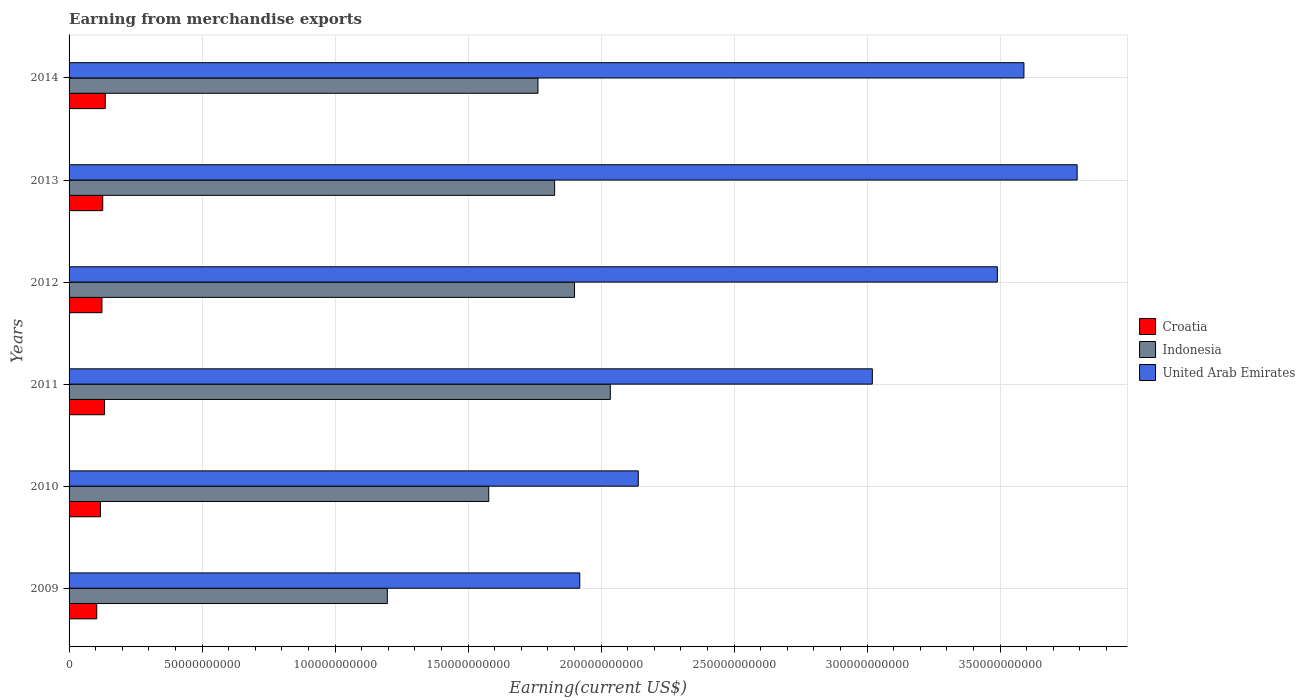How many different coloured bars are there?
Your answer should be compact. 3. How many groups of bars are there?
Make the answer very short. 6. Are the number of bars per tick equal to the number of legend labels?
Your answer should be very brief. Yes. How many bars are there on the 3rd tick from the top?
Give a very brief answer. 3. How many bars are there on the 4th tick from the bottom?
Provide a succinct answer. 3. What is the label of the 1st group of bars from the top?
Keep it short and to the point. 2014. What is the amount earned from merchandise exports in United Arab Emirates in 2012?
Give a very brief answer. 3.49e+11. Across all years, what is the maximum amount earned from merchandise exports in Indonesia?
Provide a succinct answer. 2.03e+11. Across all years, what is the minimum amount earned from merchandise exports in Croatia?
Ensure brevity in your answer.  1.04e+1. In which year was the amount earned from merchandise exports in Indonesia maximum?
Provide a short and direct response. 2011. What is the total amount earned from merchandise exports in Indonesia in the graph?
Give a very brief answer. 1.03e+12. What is the difference between the amount earned from merchandise exports in Indonesia in 2011 and that in 2013?
Offer a terse response. 2.09e+1. What is the difference between the amount earned from merchandise exports in United Arab Emirates in 2009 and the amount earned from merchandise exports in Croatia in 2013?
Ensure brevity in your answer.  1.79e+11. What is the average amount earned from merchandise exports in Indonesia per year?
Give a very brief answer. 1.72e+11. In the year 2012, what is the difference between the amount earned from merchandise exports in Croatia and amount earned from merchandise exports in United Arab Emirates?
Your response must be concise. -3.37e+11. What is the ratio of the amount earned from merchandise exports in Indonesia in 2012 to that in 2014?
Give a very brief answer. 1.08. What is the difference between the highest and the second highest amount earned from merchandise exports in Indonesia?
Ensure brevity in your answer.  1.35e+1. What is the difference between the highest and the lowest amount earned from merchandise exports in Croatia?
Offer a very short reply. 3.20e+09. In how many years, is the amount earned from merchandise exports in United Arab Emirates greater than the average amount earned from merchandise exports in United Arab Emirates taken over all years?
Your answer should be very brief. 4. What does the 1st bar from the top in 2010 represents?
Ensure brevity in your answer.  United Arab Emirates. What does the 1st bar from the bottom in 2009 represents?
Provide a short and direct response. Croatia. Is it the case that in every year, the sum of the amount earned from merchandise exports in Indonesia and amount earned from merchandise exports in Croatia is greater than the amount earned from merchandise exports in United Arab Emirates?
Provide a short and direct response. No. How many bars are there?
Make the answer very short. 18. Does the graph contain any zero values?
Give a very brief answer. No. Does the graph contain grids?
Offer a terse response. Yes. Where does the legend appear in the graph?
Ensure brevity in your answer.  Center right. How are the legend labels stacked?
Offer a terse response. Vertical. What is the title of the graph?
Offer a very short reply. Earning from merchandise exports. What is the label or title of the X-axis?
Offer a very short reply. Earning(current US$). What is the Earning(current US$) in Croatia in 2009?
Ensure brevity in your answer.  1.04e+1. What is the Earning(current US$) of Indonesia in 2009?
Your answer should be very brief. 1.20e+11. What is the Earning(current US$) in United Arab Emirates in 2009?
Ensure brevity in your answer.  1.92e+11. What is the Earning(current US$) of Croatia in 2010?
Offer a very short reply. 1.18e+1. What is the Earning(current US$) of Indonesia in 2010?
Your answer should be very brief. 1.58e+11. What is the Earning(current US$) in United Arab Emirates in 2010?
Give a very brief answer. 2.14e+11. What is the Earning(current US$) of Croatia in 2011?
Provide a succinct answer. 1.33e+1. What is the Earning(current US$) of Indonesia in 2011?
Provide a succinct answer. 2.03e+11. What is the Earning(current US$) in United Arab Emirates in 2011?
Offer a very short reply. 3.02e+11. What is the Earning(current US$) in Croatia in 2012?
Give a very brief answer. 1.24e+1. What is the Earning(current US$) of Indonesia in 2012?
Offer a terse response. 1.90e+11. What is the Earning(current US$) of United Arab Emirates in 2012?
Keep it short and to the point. 3.49e+11. What is the Earning(current US$) in Croatia in 2013?
Your response must be concise. 1.27e+1. What is the Earning(current US$) of Indonesia in 2013?
Your answer should be very brief. 1.83e+11. What is the Earning(current US$) in United Arab Emirates in 2013?
Provide a succinct answer. 3.79e+11. What is the Earning(current US$) in Croatia in 2014?
Give a very brief answer. 1.36e+1. What is the Earning(current US$) in Indonesia in 2014?
Provide a succinct answer. 1.76e+11. What is the Earning(current US$) of United Arab Emirates in 2014?
Give a very brief answer. 3.59e+11. Across all years, what is the maximum Earning(current US$) in Croatia?
Your answer should be very brief. 1.36e+1. Across all years, what is the maximum Earning(current US$) in Indonesia?
Offer a very short reply. 2.03e+11. Across all years, what is the maximum Earning(current US$) in United Arab Emirates?
Keep it short and to the point. 3.79e+11. Across all years, what is the minimum Earning(current US$) in Croatia?
Your answer should be compact. 1.04e+1. Across all years, what is the minimum Earning(current US$) of Indonesia?
Ensure brevity in your answer.  1.20e+11. Across all years, what is the minimum Earning(current US$) of United Arab Emirates?
Your response must be concise. 1.92e+11. What is the total Earning(current US$) in Croatia in the graph?
Make the answer very short. 7.42e+1. What is the total Earning(current US$) in Indonesia in the graph?
Offer a very short reply. 1.03e+12. What is the total Earning(current US$) of United Arab Emirates in the graph?
Keep it short and to the point. 1.80e+12. What is the difference between the Earning(current US$) in Croatia in 2009 and that in 2010?
Offer a terse response. -1.40e+09. What is the difference between the Earning(current US$) of Indonesia in 2009 and that in 2010?
Your answer should be compact. -3.81e+1. What is the difference between the Earning(current US$) of United Arab Emirates in 2009 and that in 2010?
Give a very brief answer. -2.20e+1. What is the difference between the Earning(current US$) in Croatia in 2009 and that in 2011?
Offer a terse response. -2.94e+09. What is the difference between the Earning(current US$) of Indonesia in 2009 and that in 2011?
Keep it short and to the point. -8.39e+1. What is the difference between the Earning(current US$) in United Arab Emirates in 2009 and that in 2011?
Make the answer very short. -1.10e+11. What is the difference between the Earning(current US$) in Croatia in 2009 and that in 2012?
Your answer should be very brief. -1.97e+09. What is the difference between the Earning(current US$) of Indonesia in 2009 and that in 2012?
Make the answer very short. -7.04e+1. What is the difference between the Earning(current US$) of United Arab Emirates in 2009 and that in 2012?
Keep it short and to the point. -1.57e+11. What is the difference between the Earning(current US$) of Croatia in 2009 and that in 2013?
Give a very brief answer. -2.26e+09. What is the difference between the Earning(current US$) of Indonesia in 2009 and that in 2013?
Provide a succinct answer. -6.29e+1. What is the difference between the Earning(current US$) of United Arab Emirates in 2009 and that in 2013?
Your response must be concise. -1.87e+11. What is the difference between the Earning(current US$) of Croatia in 2009 and that in 2014?
Offer a very short reply. -3.20e+09. What is the difference between the Earning(current US$) in Indonesia in 2009 and that in 2014?
Provide a short and direct response. -5.66e+1. What is the difference between the Earning(current US$) in United Arab Emirates in 2009 and that in 2014?
Offer a terse response. -1.67e+11. What is the difference between the Earning(current US$) of Croatia in 2010 and that in 2011?
Offer a very short reply. -1.53e+09. What is the difference between the Earning(current US$) in Indonesia in 2010 and that in 2011?
Keep it short and to the point. -4.57e+1. What is the difference between the Earning(current US$) in United Arab Emirates in 2010 and that in 2011?
Your answer should be very brief. -8.80e+1. What is the difference between the Earning(current US$) in Croatia in 2010 and that in 2012?
Offer a very short reply. -5.65e+08. What is the difference between the Earning(current US$) in Indonesia in 2010 and that in 2012?
Your answer should be very brief. -3.23e+1. What is the difference between the Earning(current US$) of United Arab Emirates in 2010 and that in 2012?
Ensure brevity in your answer.  -1.35e+11. What is the difference between the Earning(current US$) of Croatia in 2010 and that in 2013?
Offer a terse response. -8.53e+08. What is the difference between the Earning(current US$) of Indonesia in 2010 and that in 2013?
Keep it short and to the point. -2.48e+1. What is the difference between the Earning(current US$) in United Arab Emirates in 2010 and that in 2013?
Ensure brevity in your answer.  -1.65e+11. What is the difference between the Earning(current US$) of Croatia in 2010 and that in 2014?
Provide a short and direct response. -1.80e+09. What is the difference between the Earning(current US$) of Indonesia in 2010 and that in 2014?
Give a very brief answer. -1.85e+1. What is the difference between the Earning(current US$) of United Arab Emirates in 2010 and that in 2014?
Offer a terse response. -1.45e+11. What is the difference between the Earning(current US$) in Croatia in 2011 and that in 2012?
Offer a terse response. 9.68e+08. What is the difference between the Earning(current US$) of Indonesia in 2011 and that in 2012?
Ensure brevity in your answer.  1.35e+1. What is the difference between the Earning(current US$) of United Arab Emirates in 2011 and that in 2012?
Offer a very short reply. -4.70e+1. What is the difference between the Earning(current US$) of Croatia in 2011 and that in 2013?
Your response must be concise. 6.80e+08. What is the difference between the Earning(current US$) in Indonesia in 2011 and that in 2013?
Make the answer very short. 2.09e+1. What is the difference between the Earning(current US$) in United Arab Emirates in 2011 and that in 2013?
Keep it short and to the point. -7.70e+1. What is the difference between the Earning(current US$) of Croatia in 2011 and that in 2014?
Keep it short and to the point. -2.66e+08. What is the difference between the Earning(current US$) in Indonesia in 2011 and that in 2014?
Provide a short and direct response. 2.72e+1. What is the difference between the Earning(current US$) of United Arab Emirates in 2011 and that in 2014?
Your answer should be very brief. -5.70e+1. What is the difference between the Earning(current US$) in Croatia in 2012 and that in 2013?
Your answer should be very brief. -2.88e+08. What is the difference between the Earning(current US$) in Indonesia in 2012 and that in 2013?
Offer a terse response. 7.48e+09. What is the difference between the Earning(current US$) of United Arab Emirates in 2012 and that in 2013?
Give a very brief answer. -3.00e+1. What is the difference between the Earning(current US$) of Croatia in 2012 and that in 2014?
Give a very brief answer. -1.23e+09. What is the difference between the Earning(current US$) in Indonesia in 2012 and that in 2014?
Make the answer very short. 1.37e+1. What is the difference between the Earning(current US$) in United Arab Emirates in 2012 and that in 2014?
Your answer should be very brief. -1.00e+1. What is the difference between the Earning(current US$) of Croatia in 2013 and that in 2014?
Ensure brevity in your answer.  -9.46e+08. What is the difference between the Earning(current US$) in Indonesia in 2013 and that in 2014?
Make the answer very short. 6.26e+09. What is the difference between the Earning(current US$) in Croatia in 2009 and the Earning(current US$) in Indonesia in 2010?
Your answer should be very brief. -1.47e+11. What is the difference between the Earning(current US$) of Croatia in 2009 and the Earning(current US$) of United Arab Emirates in 2010?
Ensure brevity in your answer.  -2.04e+11. What is the difference between the Earning(current US$) in Indonesia in 2009 and the Earning(current US$) in United Arab Emirates in 2010?
Make the answer very short. -9.44e+1. What is the difference between the Earning(current US$) in Croatia in 2009 and the Earning(current US$) in Indonesia in 2011?
Provide a succinct answer. -1.93e+11. What is the difference between the Earning(current US$) in Croatia in 2009 and the Earning(current US$) in United Arab Emirates in 2011?
Your answer should be compact. -2.92e+11. What is the difference between the Earning(current US$) of Indonesia in 2009 and the Earning(current US$) of United Arab Emirates in 2011?
Make the answer very short. -1.82e+11. What is the difference between the Earning(current US$) in Croatia in 2009 and the Earning(current US$) in Indonesia in 2012?
Give a very brief answer. -1.80e+11. What is the difference between the Earning(current US$) of Croatia in 2009 and the Earning(current US$) of United Arab Emirates in 2012?
Offer a terse response. -3.39e+11. What is the difference between the Earning(current US$) in Indonesia in 2009 and the Earning(current US$) in United Arab Emirates in 2012?
Give a very brief answer. -2.29e+11. What is the difference between the Earning(current US$) of Croatia in 2009 and the Earning(current US$) of Indonesia in 2013?
Give a very brief answer. -1.72e+11. What is the difference between the Earning(current US$) in Croatia in 2009 and the Earning(current US$) in United Arab Emirates in 2013?
Your answer should be compact. -3.69e+11. What is the difference between the Earning(current US$) in Indonesia in 2009 and the Earning(current US$) in United Arab Emirates in 2013?
Provide a succinct answer. -2.59e+11. What is the difference between the Earning(current US$) of Croatia in 2009 and the Earning(current US$) of Indonesia in 2014?
Your answer should be very brief. -1.66e+11. What is the difference between the Earning(current US$) in Croatia in 2009 and the Earning(current US$) in United Arab Emirates in 2014?
Make the answer very short. -3.49e+11. What is the difference between the Earning(current US$) in Indonesia in 2009 and the Earning(current US$) in United Arab Emirates in 2014?
Offer a terse response. -2.39e+11. What is the difference between the Earning(current US$) of Croatia in 2010 and the Earning(current US$) of Indonesia in 2011?
Provide a short and direct response. -1.92e+11. What is the difference between the Earning(current US$) in Croatia in 2010 and the Earning(current US$) in United Arab Emirates in 2011?
Your answer should be compact. -2.90e+11. What is the difference between the Earning(current US$) of Indonesia in 2010 and the Earning(current US$) of United Arab Emirates in 2011?
Your response must be concise. -1.44e+11. What is the difference between the Earning(current US$) in Croatia in 2010 and the Earning(current US$) in Indonesia in 2012?
Offer a very short reply. -1.78e+11. What is the difference between the Earning(current US$) in Croatia in 2010 and the Earning(current US$) in United Arab Emirates in 2012?
Give a very brief answer. -3.37e+11. What is the difference between the Earning(current US$) in Indonesia in 2010 and the Earning(current US$) in United Arab Emirates in 2012?
Provide a succinct answer. -1.91e+11. What is the difference between the Earning(current US$) of Croatia in 2010 and the Earning(current US$) of Indonesia in 2013?
Give a very brief answer. -1.71e+11. What is the difference between the Earning(current US$) of Croatia in 2010 and the Earning(current US$) of United Arab Emirates in 2013?
Your response must be concise. -3.67e+11. What is the difference between the Earning(current US$) in Indonesia in 2010 and the Earning(current US$) in United Arab Emirates in 2013?
Give a very brief answer. -2.21e+11. What is the difference between the Earning(current US$) in Croatia in 2010 and the Earning(current US$) in Indonesia in 2014?
Your response must be concise. -1.64e+11. What is the difference between the Earning(current US$) of Croatia in 2010 and the Earning(current US$) of United Arab Emirates in 2014?
Your answer should be very brief. -3.47e+11. What is the difference between the Earning(current US$) in Indonesia in 2010 and the Earning(current US$) in United Arab Emirates in 2014?
Give a very brief answer. -2.01e+11. What is the difference between the Earning(current US$) in Croatia in 2011 and the Earning(current US$) in Indonesia in 2012?
Offer a very short reply. -1.77e+11. What is the difference between the Earning(current US$) in Croatia in 2011 and the Earning(current US$) in United Arab Emirates in 2012?
Provide a succinct answer. -3.36e+11. What is the difference between the Earning(current US$) in Indonesia in 2011 and the Earning(current US$) in United Arab Emirates in 2012?
Offer a very short reply. -1.46e+11. What is the difference between the Earning(current US$) of Croatia in 2011 and the Earning(current US$) of Indonesia in 2013?
Your answer should be compact. -1.69e+11. What is the difference between the Earning(current US$) in Croatia in 2011 and the Earning(current US$) in United Arab Emirates in 2013?
Provide a succinct answer. -3.66e+11. What is the difference between the Earning(current US$) in Indonesia in 2011 and the Earning(current US$) in United Arab Emirates in 2013?
Provide a short and direct response. -1.76e+11. What is the difference between the Earning(current US$) in Croatia in 2011 and the Earning(current US$) in Indonesia in 2014?
Your response must be concise. -1.63e+11. What is the difference between the Earning(current US$) of Croatia in 2011 and the Earning(current US$) of United Arab Emirates in 2014?
Your response must be concise. -3.46e+11. What is the difference between the Earning(current US$) in Indonesia in 2011 and the Earning(current US$) in United Arab Emirates in 2014?
Provide a succinct answer. -1.56e+11. What is the difference between the Earning(current US$) of Croatia in 2012 and the Earning(current US$) of Indonesia in 2013?
Offer a terse response. -1.70e+11. What is the difference between the Earning(current US$) in Croatia in 2012 and the Earning(current US$) in United Arab Emirates in 2013?
Ensure brevity in your answer.  -3.67e+11. What is the difference between the Earning(current US$) of Indonesia in 2012 and the Earning(current US$) of United Arab Emirates in 2013?
Give a very brief answer. -1.89e+11. What is the difference between the Earning(current US$) in Croatia in 2012 and the Earning(current US$) in Indonesia in 2014?
Provide a succinct answer. -1.64e+11. What is the difference between the Earning(current US$) of Croatia in 2012 and the Earning(current US$) of United Arab Emirates in 2014?
Give a very brief answer. -3.47e+11. What is the difference between the Earning(current US$) of Indonesia in 2012 and the Earning(current US$) of United Arab Emirates in 2014?
Provide a succinct answer. -1.69e+11. What is the difference between the Earning(current US$) in Croatia in 2013 and the Earning(current US$) in Indonesia in 2014?
Your response must be concise. -1.64e+11. What is the difference between the Earning(current US$) of Croatia in 2013 and the Earning(current US$) of United Arab Emirates in 2014?
Offer a terse response. -3.46e+11. What is the difference between the Earning(current US$) of Indonesia in 2013 and the Earning(current US$) of United Arab Emirates in 2014?
Ensure brevity in your answer.  -1.76e+11. What is the average Earning(current US$) in Croatia per year?
Give a very brief answer. 1.24e+1. What is the average Earning(current US$) of Indonesia per year?
Provide a short and direct response. 1.72e+11. What is the average Earning(current US$) in United Arab Emirates per year?
Keep it short and to the point. 2.99e+11. In the year 2009, what is the difference between the Earning(current US$) in Croatia and Earning(current US$) in Indonesia?
Make the answer very short. -1.09e+11. In the year 2009, what is the difference between the Earning(current US$) of Croatia and Earning(current US$) of United Arab Emirates?
Offer a terse response. -1.82e+11. In the year 2009, what is the difference between the Earning(current US$) in Indonesia and Earning(current US$) in United Arab Emirates?
Your answer should be compact. -7.24e+1. In the year 2010, what is the difference between the Earning(current US$) in Croatia and Earning(current US$) in Indonesia?
Your answer should be compact. -1.46e+11. In the year 2010, what is the difference between the Earning(current US$) of Croatia and Earning(current US$) of United Arab Emirates?
Make the answer very short. -2.02e+11. In the year 2010, what is the difference between the Earning(current US$) of Indonesia and Earning(current US$) of United Arab Emirates?
Keep it short and to the point. -5.62e+1. In the year 2011, what is the difference between the Earning(current US$) in Croatia and Earning(current US$) in Indonesia?
Your response must be concise. -1.90e+11. In the year 2011, what is the difference between the Earning(current US$) in Croatia and Earning(current US$) in United Arab Emirates?
Your answer should be very brief. -2.89e+11. In the year 2011, what is the difference between the Earning(current US$) of Indonesia and Earning(current US$) of United Arab Emirates?
Keep it short and to the point. -9.85e+1. In the year 2012, what is the difference between the Earning(current US$) of Croatia and Earning(current US$) of Indonesia?
Offer a very short reply. -1.78e+11. In the year 2012, what is the difference between the Earning(current US$) of Croatia and Earning(current US$) of United Arab Emirates?
Make the answer very short. -3.37e+11. In the year 2012, what is the difference between the Earning(current US$) in Indonesia and Earning(current US$) in United Arab Emirates?
Your answer should be compact. -1.59e+11. In the year 2013, what is the difference between the Earning(current US$) of Croatia and Earning(current US$) of Indonesia?
Your answer should be very brief. -1.70e+11. In the year 2013, what is the difference between the Earning(current US$) of Croatia and Earning(current US$) of United Arab Emirates?
Make the answer very short. -3.66e+11. In the year 2013, what is the difference between the Earning(current US$) in Indonesia and Earning(current US$) in United Arab Emirates?
Provide a succinct answer. -1.96e+11. In the year 2014, what is the difference between the Earning(current US$) of Croatia and Earning(current US$) of Indonesia?
Make the answer very short. -1.63e+11. In the year 2014, what is the difference between the Earning(current US$) in Croatia and Earning(current US$) in United Arab Emirates?
Ensure brevity in your answer.  -3.45e+11. In the year 2014, what is the difference between the Earning(current US$) in Indonesia and Earning(current US$) in United Arab Emirates?
Provide a succinct answer. -1.83e+11. What is the ratio of the Earning(current US$) of Croatia in 2009 to that in 2010?
Ensure brevity in your answer.  0.88. What is the ratio of the Earning(current US$) of Indonesia in 2009 to that in 2010?
Provide a succinct answer. 0.76. What is the ratio of the Earning(current US$) in United Arab Emirates in 2009 to that in 2010?
Offer a terse response. 0.9. What is the ratio of the Earning(current US$) in Croatia in 2009 to that in 2011?
Provide a short and direct response. 0.78. What is the ratio of the Earning(current US$) in Indonesia in 2009 to that in 2011?
Make the answer very short. 0.59. What is the ratio of the Earning(current US$) of United Arab Emirates in 2009 to that in 2011?
Make the answer very short. 0.64. What is the ratio of the Earning(current US$) of Croatia in 2009 to that in 2012?
Your answer should be compact. 0.84. What is the ratio of the Earning(current US$) of Indonesia in 2009 to that in 2012?
Provide a succinct answer. 0.63. What is the ratio of the Earning(current US$) in United Arab Emirates in 2009 to that in 2012?
Your answer should be compact. 0.55. What is the ratio of the Earning(current US$) of Croatia in 2009 to that in 2013?
Keep it short and to the point. 0.82. What is the ratio of the Earning(current US$) of Indonesia in 2009 to that in 2013?
Provide a short and direct response. 0.66. What is the ratio of the Earning(current US$) of United Arab Emirates in 2009 to that in 2013?
Provide a short and direct response. 0.51. What is the ratio of the Earning(current US$) in Croatia in 2009 to that in 2014?
Ensure brevity in your answer.  0.76. What is the ratio of the Earning(current US$) of Indonesia in 2009 to that in 2014?
Offer a terse response. 0.68. What is the ratio of the Earning(current US$) in United Arab Emirates in 2009 to that in 2014?
Offer a very short reply. 0.53. What is the ratio of the Earning(current US$) of Croatia in 2010 to that in 2011?
Ensure brevity in your answer.  0.89. What is the ratio of the Earning(current US$) of Indonesia in 2010 to that in 2011?
Offer a very short reply. 0.78. What is the ratio of the Earning(current US$) in United Arab Emirates in 2010 to that in 2011?
Give a very brief answer. 0.71. What is the ratio of the Earning(current US$) in Croatia in 2010 to that in 2012?
Give a very brief answer. 0.95. What is the ratio of the Earning(current US$) of Indonesia in 2010 to that in 2012?
Offer a very short reply. 0.83. What is the ratio of the Earning(current US$) in United Arab Emirates in 2010 to that in 2012?
Offer a very short reply. 0.61. What is the ratio of the Earning(current US$) of Croatia in 2010 to that in 2013?
Provide a short and direct response. 0.93. What is the ratio of the Earning(current US$) in Indonesia in 2010 to that in 2013?
Keep it short and to the point. 0.86. What is the ratio of the Earning(current US$) of United Arab Emirates in 2010 to that in 2013?
Ensure brevity in your answer.  0.56. What is the ratio of the Earning(current US$) of Croatia in 2010 to that in 2014?
Offer a very short reply. 0.87. What is the ratio of the Earning(current US$) in Indonesia in 2010 to that in 2014?
Ensure brevity in your answer.  0.9. What is the ratio of the Earning(current US$) of United Arab Emirates in 2010 to that in 2014?
Your response must be concise. 0.6. What is the ratio of the Earning(current US$) in Croatia in 2011 to that in 2012?
Give a very brief answer. 1.08. What is the ratio of the Earning(current US$) of Indonesia in 2011 to that in 2012?
Your response must be concise. 1.07. What is the ratio of the Earning(current US$) of United Arab Emirates in 2011 to that in 2012?
Give a very brief answer. 0.87. What is the ratio of the Earning(current US$) in Croatia in 2011 to that in 2013?
Offer a very short reply. 1.05. What is the ratio of the Earning(current US$) of Indonesia in 2011 to that in 2013?
Give a very brief answer. 1.11. What is the ratio of the Earning(current US$) in United Arab Emirates in 2011 to that in 2013?
Provide a short and direct response. 0.8. What is the ratio of the Earning(current US$) in Croatia in 2011 to that in 2014?
Make the answer very short. 0.98. What is the ratio of the Earning(current US$) in Indonesia in 2011 to that in 2014?
Your answer should be very brief. 1.15. What is the ratio of the Earning(current US$) of United Arab Emirates in 2011 to that in 2014?
Make the answer very short. 0.84. What is the ratio of the Earning(current US$) in Croatia in 2012 to that in 2013?
Offer a terse response. 0.98. What is the ratio of the Earning(current US$) of Indonesia in 2012 to that in 2013?
Ensure brevity in your answer.  1.04. What is the ratio of the Earning(current US$) of United Arab Emirates in 2012 to that in 2013?
Your response must be concise. 0.92. What is the ratio of the Earning(current US$) in Croatia in 2012 to that in 2014?
Provide a short and direct response. 0.91. What is the ratio of the Earning(current US$) of Indonesia in 2012 to that in 2014?
Give a very brief answer. 1.08. What is the ratio of the Earning(current US$) of United Arab Emirates in 2012 to that in 2014?
Ensure brevity in your answer.  0.97. What is the ratio of the Earning(current US$) in Croatia in 2013 to that in 2014?
Provide a short and direct response. 0.93. What is the ratio of the Earning(current US$) in Indonesia in 2013 to that in 2014?
Offer a terse response. 1.04. What is the ratio of the Earning(current US$) of United Arab Emirates in 2013 to that in 2014?
Offer a terse response. 1.06. What is the difference between the highest and the second highest Earning(current US$) of Croatia?
Keep it short and to the point. 2.66e+08. What is the difference between the highest and the second highest Earning(current US$) in Indonesia?
Provide a short and direct response. 1.35e+1. What is the difference between the highest and the lowest Earning(current US$) in Croatia?
Offer a terse response. 3.20e+09. What is the difference between the highest and the lowest Earning(current US$) in Indonesia?
Offer a very short reply. 8.39e+1. What is the difference between the highest and the lowest Earning(current US$) of United Arab Emirates?
Provide a succinct answer. 1.87e+11. 